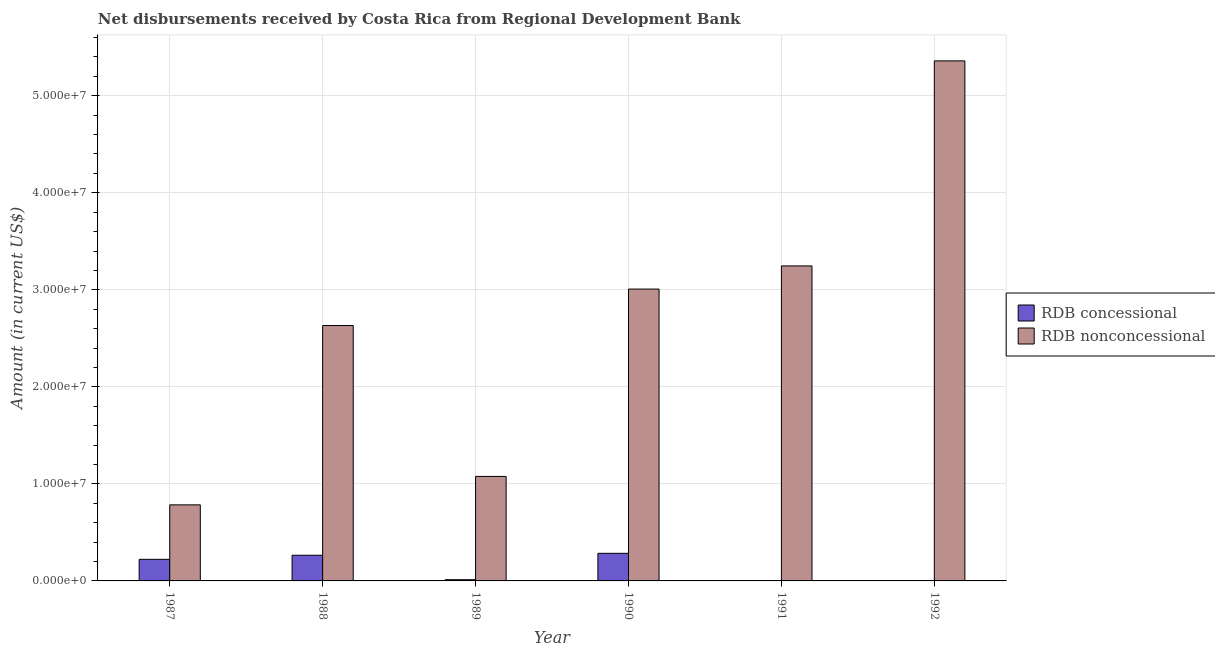How many bars are there on the 4th tick from the right?
Provide a succinct answer. 2. What is the label of the 2nd group of bars from the left?
Your answer should be compact. 1988. Across all years, what is the maximum net concessional disbursements from rdb?
Your answer should be compact. 2.84e+06. Across all years, what is the minimum net non concessional disbursements from rdb?
Ensure brevity in your answer.  7.84e+06. What is the total net concessional disbursements from rdb in the graph?
Ensure brevity in your answer.  7.85e+06. What is the difference between the net non concessional disbursements from rdb in 1989 and that in 1991?
Your answer should be very brief. -2.17e+07. What is the difference between the net concessional disbursements from rdb in 1990 and the net non concessional disbursements from rdb in 1989?
Ensure brevity in your answer.  2.72e+06. What is the average net concessional disbursements from rdb per year?
Your answer should be compact. 1.31e+06. In how many years, is the net non concessional disbursements from rdb greater than 38000000 US$?
Offer a terse response. 1. What is the ratio of the net non concessional disbursements from rdb in 1988 to that in 1990?
Offer a terse response. 0.88. What is the difference between the highest and the second highest net non concessional disbursements from rdb?
Provide a short and direct response. 2.11e+07. What is the difference between the highest and the lowest net non concessional disbursements from rdb?
Your response must be concise. 4.58e+07. How many years are there in the graph?
Your answer should be very brief. 6. Are the values on the major ticks of Y-axis written in scientific E-notation?
Your answer should be compact. Yes. Does the graph contain any zero values?
Offer a very short reply. Yes. Does the graph contain grids?
Keep it short and to the point. Yes. What is the title of the graph?
Provide a succinct answer. Net disbursements received by Costa Rica from Regional Development Bank. What is the label or title of the X-axis?
Provide a short and direct response. Year. What is the Amount (in current US$) of RDB concessional in 1987?
Provide a short and direct response. 2.23e+06. What is the Amount (in current US$) of RDB nonconcessional in 1987?
Your response must be concise. 7.84e+06. What is the Amount (in current US$) of RDB concessional in 1988?
Ensure brevity in your answer.  2.65e+06. What is the Amount (in current US$) in RDB nonconcessional in 1988?
Offer a very short reply. 2.63e+07. What is the Amount (in current US$) of RDB concessional in 1989?
Offer a very short reply. 1.27e+05. What is the Amount (in current US$) in RDB nonconcessional in 1989?
Provide a short and direct response. 1.08e+07. What is the Amount (in current US$) of RDB concessional in 1990?
Ensure brevity in your answer.  2.84e+06. What is the Amount (in current US$) of RDB nonconcessional in 1990?
Your response must be concise. 3.01e+07. What is the Amount (in current US$) of RDB concessional in 1991?
Keep it short and to the point. 0. What is the Amount (in current US$) in RDB nonconcessional in 1991?
Give a very brief answer. 3.25e+07. What is the Amount (in current US$) of RDB concessional in 1992?
Your answer should be very brief. 0. What is the Amount (in current US$) in RDB nonconcessional in 1992?
Provide a short and direct response. 5.36e+07. Across all years, what is the maximum Amount (in current US$) of RDB concessional?
Provide a short and direct response. 2.84e+06. Across all years, what is the maximum Amount (in current US$) in RDB nonconcessional?
Offer a very short reply. 5.36e+07. Across all years, what is the minimum Amount (in current US$) of RDB concessional?
Offer a terse response. 0. Across all years, what is the minimum Amount (in current US$) in RDB nonconcessional?
Make the answer very short. 7.84e+06. What is the total Amount (in current US$) in RDB concessional in the graph?
Provide a succinct answer. 7.85e+06. What is the total Amount (in current US$) in RDB nonconcessional in the graph?
Your response must be concise. 1.61e+08. What is the difference between the Amount (in current US$) in RDB concessional in 1987 and that in 1988?
Provide a succinct answer. -4.20e+05. What is the difference between the Amount (in current US$) in RDB nonconcessional in 1987 and that in 1988?
Offer a terse response. -1.85e+07. What is the difference between the Amount (in current US$) in RDB concessional in 1987 and that in 1989?
Ensure brevity in your answer.  2.10e+06. What is the difference between the Amount (in current US$) in RDB nonconcessional in 1987 and that in 1989?
Ensure brevity in your answer.  -2.93e+06. What is the difference between the Amount (in current US$) of RDB concessional in 1987 and that in 1990?
Offer a terse response. -6.18e+05. What is the difference between the Amount (in current US$) of RDB nonconcessional in 1987 and that in 1990?
Keep it short and to the point. -2.22e+07. What is the difference between the Amount (in current US$) of RDB nonconcessional in 1987 and that in 1991?
Make the answer very short. -2.46e+07. What is the difference between the Amount (in current US$) of RDB nonconcessional in 1987 and that in 1992?
Make the answer very short. -4.58e+07. What is the difference between the Amount (in current US$) in RDB concessional in 1988 and that in 1989?
Provide a short and direct response. 2.52e+06. What is the difference between the Amount (in current US$) in RDB nonconcessional in 1988 and that in 1989?
Ensure brevity in your answer.  1.56e+07. What is the difference between the Amount (in current US$) in RDB concessional in 1988 and that in 1990?
Your answer should be compact. -1.98e+05. What is the difference between the Amount (in current US$) of RDB nonconcessional in 1988 and that in 1990?
Offer a terse response. -3.76e+06. What is the difference between the Amount (in current US$) in RDB nonconcessional in 1988 and that in 1991?
Keep it short and to the point. -6.14e+06. What is the difference between the Amount (in current US$) in RDB nonconcessional in 1988 and that in 1992?
Offer a very short reply. -2.73e+07. What is the difference between the Amount (in current US$) of RDB concessional in 1989 and that in 1990?
Keep it short and to the point. -2.72e+06. What is the difference between the Amount (in current US$) in RDB nonconcessional in 1989 and that in 1990?
Keep it short and to the point. -1.93e+07. What is the difference between the Amount (in current US$) in RDB nonconcessional in 1989 and that in 1991?
Offer a very short reply. -2.17e+07. What is the difference between the Amount (in current US$) in RDB nonconcessional in 1989 and that in 1992?
Provide a short and direct response. -4.28e+07. What is the difference between the Amount (in current US$) in RDB nonconcessional in 1990 and that in 1991?
Your answer should be very brief. -2.39e+06. What is the difference between the Amount (in current US$) in RDB nonconcessional in 1990 and that in 1992?
Your answer should be compact. -2.35e+07. What is the difference between the Amount (in current US$) in RDB nonconcessional in 1991 and that in 1992?
Keep it short and to the point. -2.11e+07. What is the difference between the Amount (in current US$) of RDB concessional in 1987 and the Amount (in current US$) of RDB nonconcessional in 1988?
Make the answer very short. -2.41e+07. What is the difference between the Amount (in current US$) in RDB concessional in 1987 and the Amount (in current US$) in RDB nonconcessional in 1989?
Ensure brevity in your answer.  -8.54e+06. What is the difference between the Amount (in current US$) of RDB concessional in 1987 and the Amount (in current US$) of RDB nonconcessional in 1990?
Your answer should be very brief. -2.79e+07. What is the difference between the Amount (in current US$) in RDB concessional in 1987 and the Amount (in current US$) in RDB nonconcessional in 1991?
Offer a terse response. -3.02e+07. What is the difference between the Amount (in current US$) of RDB concessional in 1987 and the Amount (in current US$) of RDB nonconcessional in 1992?
Offer a very short reply. -5.14e+07. What is the difference between the Amount (in current US$) of RDB concessional in 1988 and the Amount (in current US$) of RDB nonconcessional in 1989?
Your response must be concise. -8.12e+06. What is the difference between the Amount (in current US$) in RDB concessional in 1988 and the Amount (in current US$) in RDB nonconcessional in 1990?
Offer a very short reply. -2.74e+07. What is the difference between the Amount (in current US$) in RDB concessional in 1988 and the Amount (in current US$) in RDB nonconcessional in 1991?
Provide a short and direct response. -2.98e+07. What is the difference between the Amount (in current US$) in RDB concessional in 1988 and the Amount (in current US$) in RDB nonconcessional in 1992?
Make the answer very short. -5.09e+07. What is the difference between the Amount (in current US$) in RDB concessional in 1989 and the Amount (in current US$) in RDB nonconcessional in 1990?
Make the answer very short. -3.00e+07. What is the difference between the Amount (in current US$) of RDB concessional in 1989 and the Amount (in current US$) of RDB nonconcessional in 1991?
Your response must be concise. -3.23e+07. What is the difference between the Amount (in current US$) of RDB concessional in 1989 and the Amount (in current US$) of RDB nonconcessional in 1992?
Make the answer very short. -5.35e+07. What is the difference between the Amount (in current US$) in RDB concessional in 1990 and the Amount (in current US$) in RDB nonconcessional in 1991?
Your answer should be compact. -2.96e+07. What is the difference between the Amount (in current US$) in RDB concessional in 1990 and the Amount (in current US$) in RDB nonconcessional in 1992?
Provide a short and direct response. -5.08e+07. What is the average Amount (in current US$) of RDB concessional per year?
Your response must be concise. 1.31e+06. What is the average Amount (in current US$) in RDB nonconcessional per year?
Make the answer very short. 2.68e+07. In the year 1987, what is the difference between the Amount (in current US$) of RDB concessional and Amount (in current US$) of RDB nonconcessional?
Give a very brief answer. -5.61e+06. In the year 1988, what is the difference between the Amount (in current US$) of RDB concessional and Amount (in current US$) of RDB nonconcessional?
Give a very brief answer. -2.37e+07. In the year 1989, what is the difference between the Amount (in current US$) in RDB concessional and Amount (in current US$) in RDB nonconcessional?
Give a very brief answer. -1.06e+07. In the year 1990, what is the difference between the Amount (in current US$) of RDB concessional and Amount (in current US$) of RDB nonconcessional?
Your answer should be compact. -2.72e+07. What is the ratio of the Amount (in current US$) of RDB concessional in 1987 to that in 1988?
Your answer should be compact. 0.84. What is the ratio of the Amount (in current US$) in RDB nonconcessional in 1987 to that in 1988?
Offer a terse response. 0.3. What is the ratio of the Amount (in current US$) in RDB concessional in 1987 to that in 1989?
Keep it short and to the point. 17.54. What is the ratio of the Amount (in current US$) in RDB nonconcessional in 1987 to that in 1989?
Your answer should be very brief. 0.73. What is the ratio of the Amount (in current US$) in RDB concessional in 1987 to that in 1990?
Keep it short and to the point. 0.78. What is the ratio of the Amount (in current US$) in RDB nonconcessional in 1987 to that in 1990?
Make the answer very short. 0.26. What is the ratio of the Amount (in current US$) in RDB nonconcessional in 1987 to that in 1991?
Your answer should be compact. 0.24. What is the ratio of the Amount (in current US$) of RDB nonconcessional in 1987 to that in 1992?
Offer a very short reply. 0.15. What is the ratio of the Amount (in current US$) of RDB concessional in 1988 to that in 1989?
Your answer should be compact. 20.84. What is the ratio of the Amount (in current US$) in RDB nonconcessional in 1988 to that in 1989?
Your response must be concise. 2.44. What is the ratio of the Amount (in current US$) in RDB concessional in 1988 to that in 1990?
Your response must be concise. 0.93. What is the ratio of the Amount (in current US$) of RDB nonconcessional in 1988 to that in 1990?
Give a very brief answer. 0.88. What is the ratio of the Amount (in current US$) in RDB nonconcessional in 1988 to that in 1991?
Give a very brief answer. 0.81. What is the ratio of the Amount (in current US$) in RDB nonconcessional in 1988 to that in 1992?
Make the answer very short. 0.49. What is the ratio of the Amount (in current US$) in RDB concessional in 1989 to that in 1990?
Keep it short and to the point. 0.04. What is the ratio of the Amount (in current US$) of RDB nonconcessional in 1989 to that in 1990?
Give a very brief answer. 0.36. What is the ratio of the Amount (in current US$) in RDB nonconcessional in 1989 to that in 1991?
Your answer should be very brief. 0.33. What is the ratio of the Amount (in current US$) of RDB nonconcessional in 1989 to that in 1992?
Make the answer very short. 0.2. What is the ratio of the Amount (in current US$) of RDB nonconcessional in 1990 to that in 1991?
Provide a succinct answer. 0.93. What is the ratio of the Amount (in current US$) in RDB nonconcessional in 1990 to that in 1992?
Give a very brief answer. 0.56. What is the ratio of the Amount (in current US$) in RDB nonconcessional in 1991 to that in 1992?
Give a very brief answer. 0.61. What is the difference between the highest and the second highest Amount (in current US$) in RDB concessional?
Your answer should be compact. 1.98e+05. What is the difference between the highest and the second highest Amount (in current US$) in RDB nonconcessional?
Your answer should be compact. 2.11e+07. What is the difference between the highest and the lowest Amount (in current US$) of RDB concessional?
Provide a short and direct response. 2.84e+06. What is the difference between the highest and the lowest Amount (in current US$) of RDB nonconcessional?
Ensure brevity in your answer.  4.58e+07. 